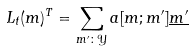Convert formula to latex. <formula><loc_0><loc_0><loc_500><loc_500>L _ { t } ( m ) ^ { T } = \sum _ { m ^ { \prime } \colon \mathcal { Y } } a [ m ; m ^ { \prime } ] \underline { m ^ { \prime } }</formula> 